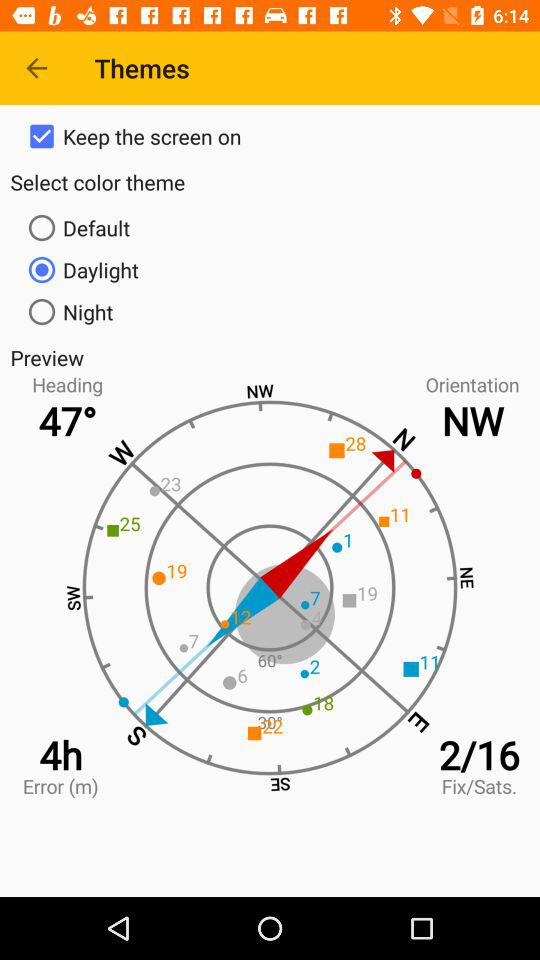What is the given "Error (m)"? The given "Error (m)" is 4h. 